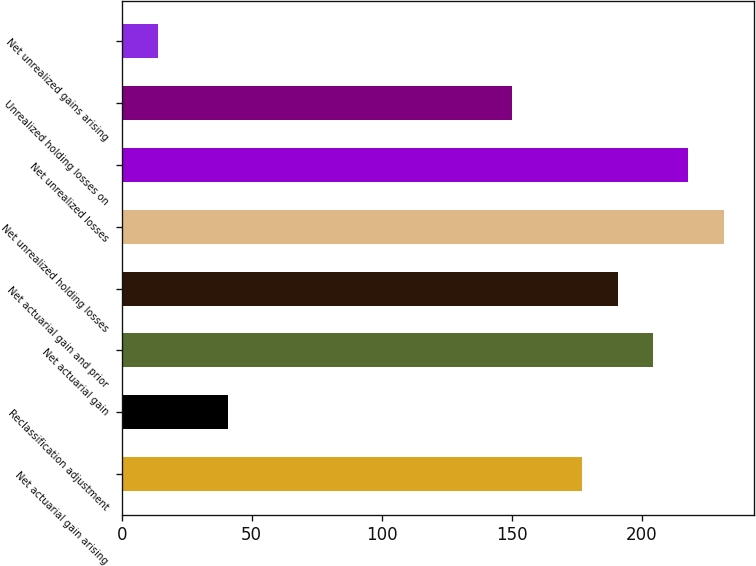<chart> <loc_0><loc_0><loc_500><loc_500><bar_chart><fcel>Net actuarial gain arising<fcel>Reclassification adjustment<fcel>Net actuarial gain<fcel>Net actuarial gain and prior<fcel>Net unrealized holding losses<fcel>Net unrealized losses<fcel>Unrealized holding losses on<fcel>Net unrealized gains arising<nl><fcel>177.13<fcel>41.03<fcel>204.35<fcel>190.74<fcel>231.57<fcel>217.96<fcel>149.91<fcel>13.81<nl></chart> 